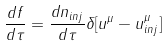Convert formula to latex. <formula><loc_0><loc_0><loc_500><loc_500>\frac { d f } { d \tau } = \frac { d n _ { i n j } } { d \tau } \delta [ u ^ { \mu } - u ^ { \mu } _ { i n j } ]</formula> 